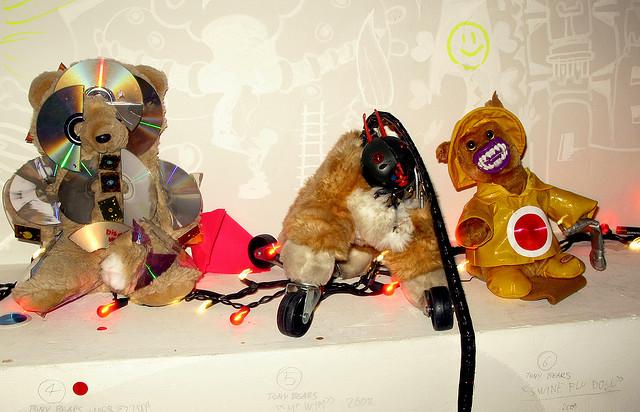What style of art is this?
Answer briefly. Modern. What is on the bear to the left?
Answer briefly. Cds. Are there Christmas lights?
Keep it brief. Yes. 